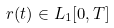<formula> <loc_0><loc_0><loc_500><loc_500>r ( t ) \in L _ { 1 } [ 0 , T ]</formula> 